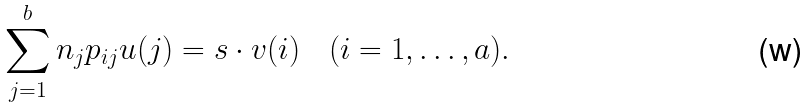Convert formula to latex. <formula><loc_0><loc_0><loc_500><loc_500>\sum _ { j = 1 } ^ { b } n _ { j } p _ { i j } u ( j ) = s \cdot v ( i ) \quad ( i = 1 , \dots , a ) .</formula> 